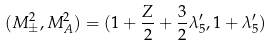Convert formula to latex. <formula><loc_0><loc_0><loc_500><loc_500>( M ^ { 2 } _ { \pm } , M ^ { 2 } _ { A } ) = ( 1 + \frac { Z } { 2 } + \frac { 3 } { 2 } \lambda ^ { \prime } _ { 5 } , 1 + \lambda ^ { \prime } _ { 5 } )</formula> 